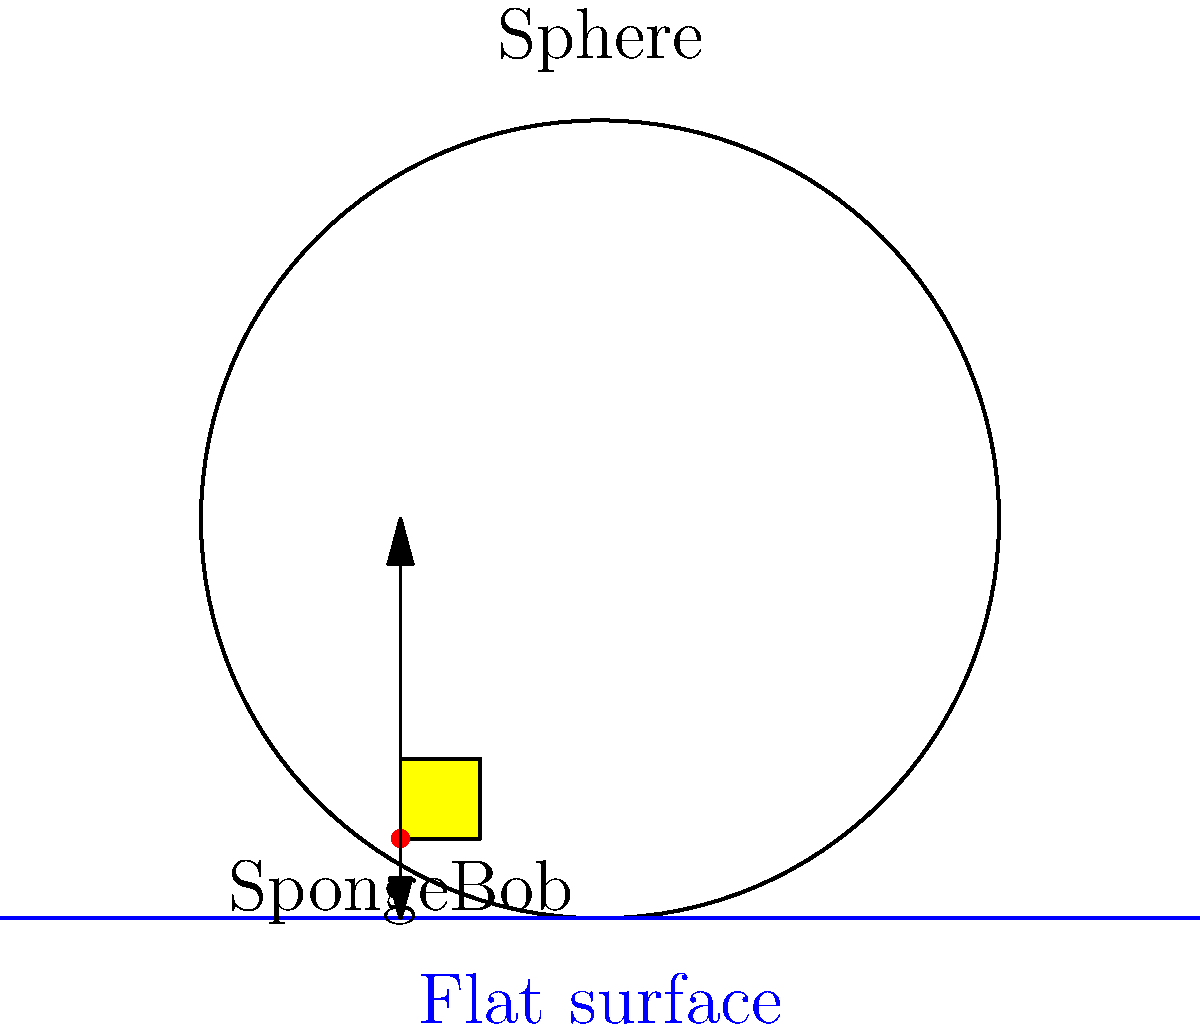SpongeBob is standing on a flat surface next to a giant sphere. If he walks the same distance on the sphere's surface as he does on the flat surface, which path will appear straighter to him? Explain your answer using what you know about the curvature of a sphere compared to a flat surface. Let's think about this step-by-step:

1. On a flat surface:
   - The path SpongeBob walks will be a straight line.
   - The distance between any two points is always the shortest possible path.

2. On a sphere's surface:
   - The path SpongeBob walks will actually be part of a great circle (the largest circle that can be drawn on a sphere).
   - Due to the curvature of the sphere, this path will appear curved when viewed from outside the sphere.

3. Curvature comparison:
   - A flat surface has zero curvature.
   - A sphere has constant positive curvature.

4. SpongeBob's perspective:
   - On the flat surface, SpongeBob will see his path as straight.
   - On the sphere, SpongeBob will also perceive his path as straight, even though it's curved from an outside perspective.

5. The reason for this perception:
   - The curvature of the sphere is uniform in all directions.
   - SpongeBob doesn't have an external reference point to notice the curvature.

6. Mathematical explanation:
   - On a flat surface, the shortest path between two points is given by the equation of a straight line: $y = mx + b$
   - On a sphere, the shortest path (geodesic) is part of a great circle, which can be described using spherical coordinates.

Therefore, from SpongeBob's perspective, both paths will appear equally straight, even though the path on the sphere is actually curved when viewed from outside.
Answer: Both paths will appear equally straight to SpongeBob. 